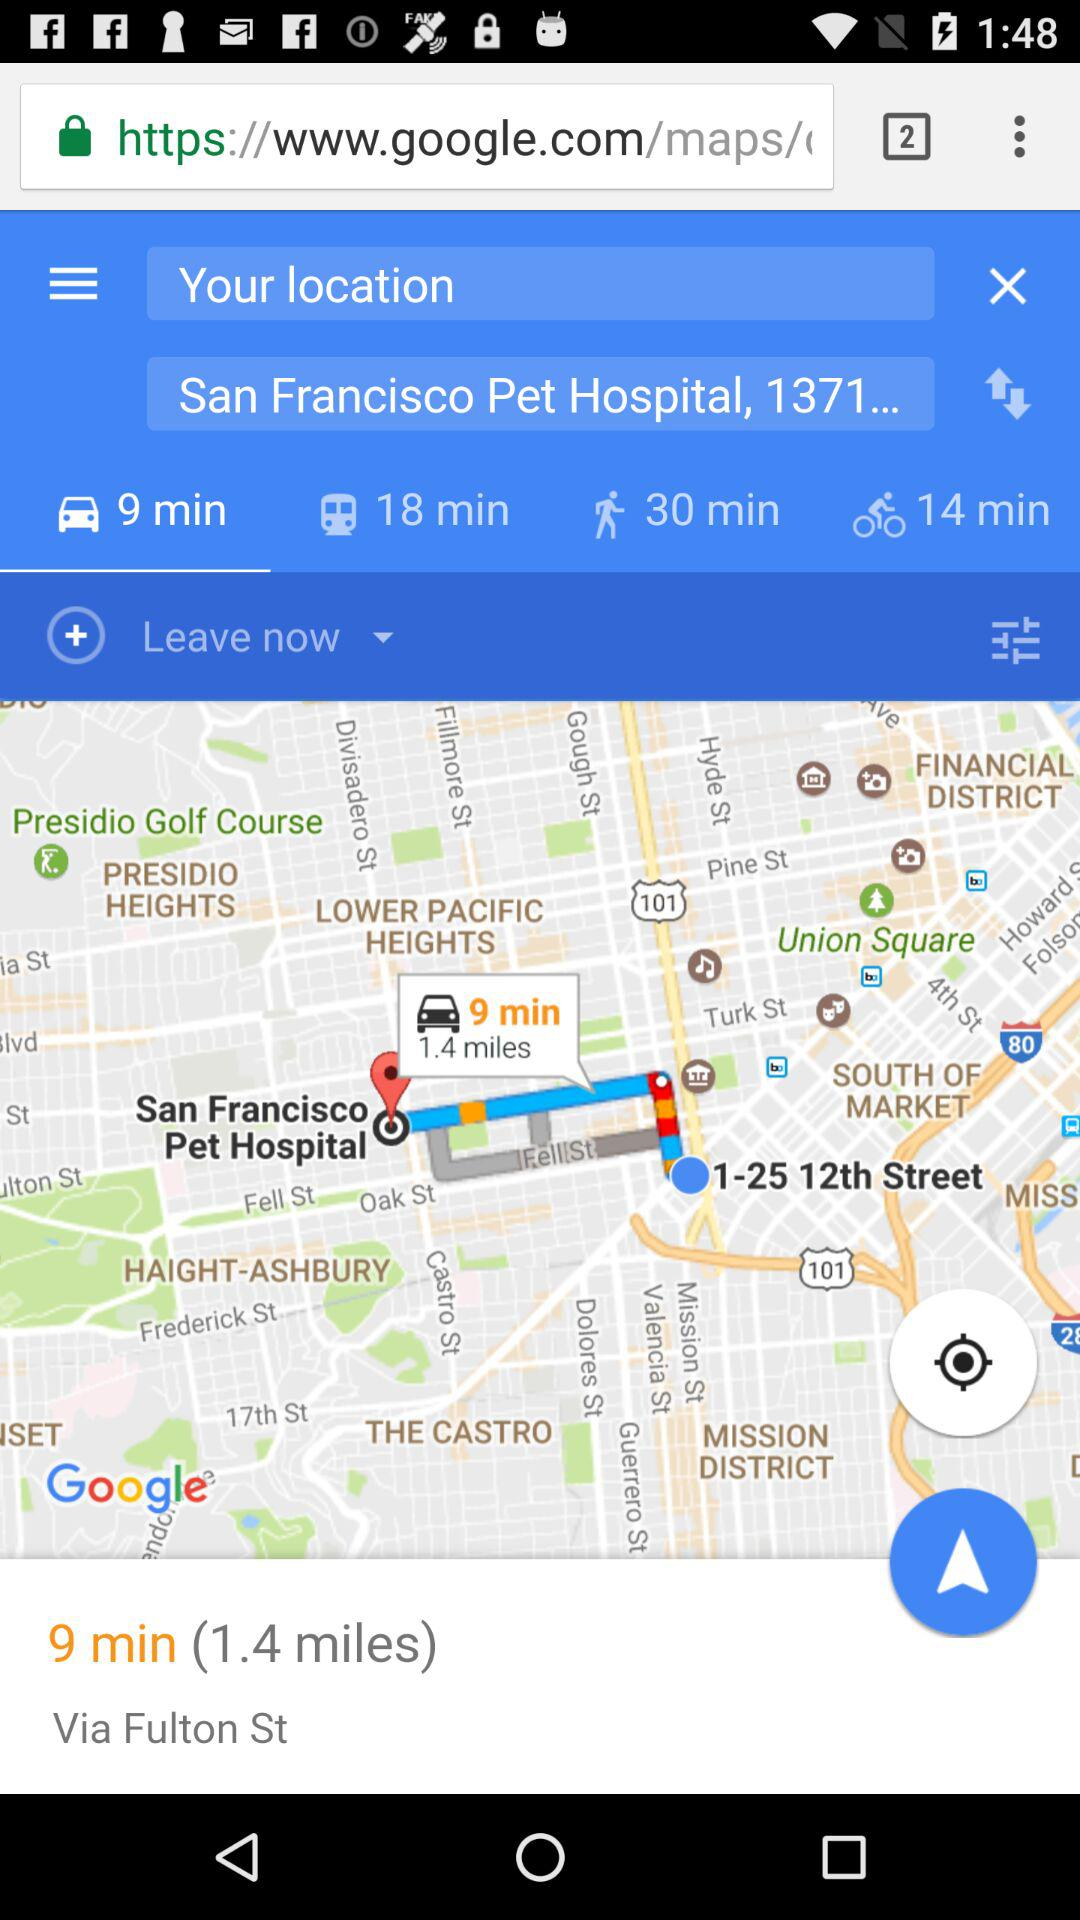How many minutes is the shortest travel time?
Answer the question using a single word or phrase. 9 min 